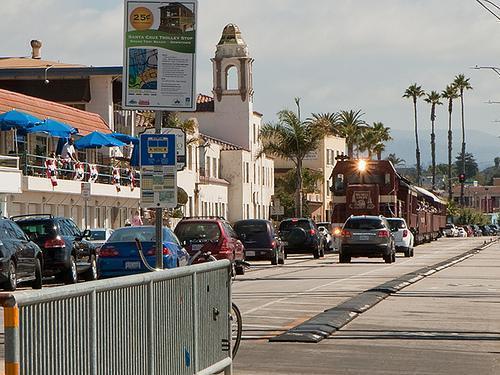How many balconies have umbrellas?
Give a very brief answer. 1. 